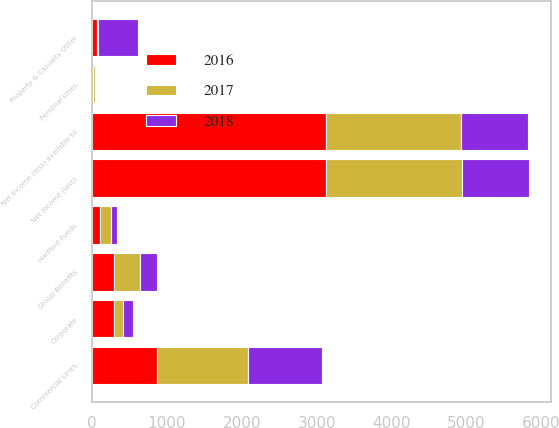Convert chart to OTSL. <chart><loc_0><loc_0><loc_500><loc_500><stacked_bar_chart><ecel><fcel>Commercial Lines<fcel>Personal Lines<fcel>Property & Casualty Other<fcel>Group Benefits<fcel>Hartford Funds<fcel>Corporate<fcel>Net income (loss)<fcel>Net income (loss) available to<nl><fcel>2017<fcel>1212<fcel>32<fcel>15<fcel>340<fcel>148<fcel>124<fcel>1807<fcel>1801<nl><fcel>2016<fcel>865<fcel>9<fcel>69<fcel>294<fcel>106<fcel>294<fcel>3131<fcel>3131<nl><fcel>2018<fcel>994<fcel>9<fcel>529<fcel>230<fcel>78<fcel>132<fcel>896<fcel>896<nl></chart> 